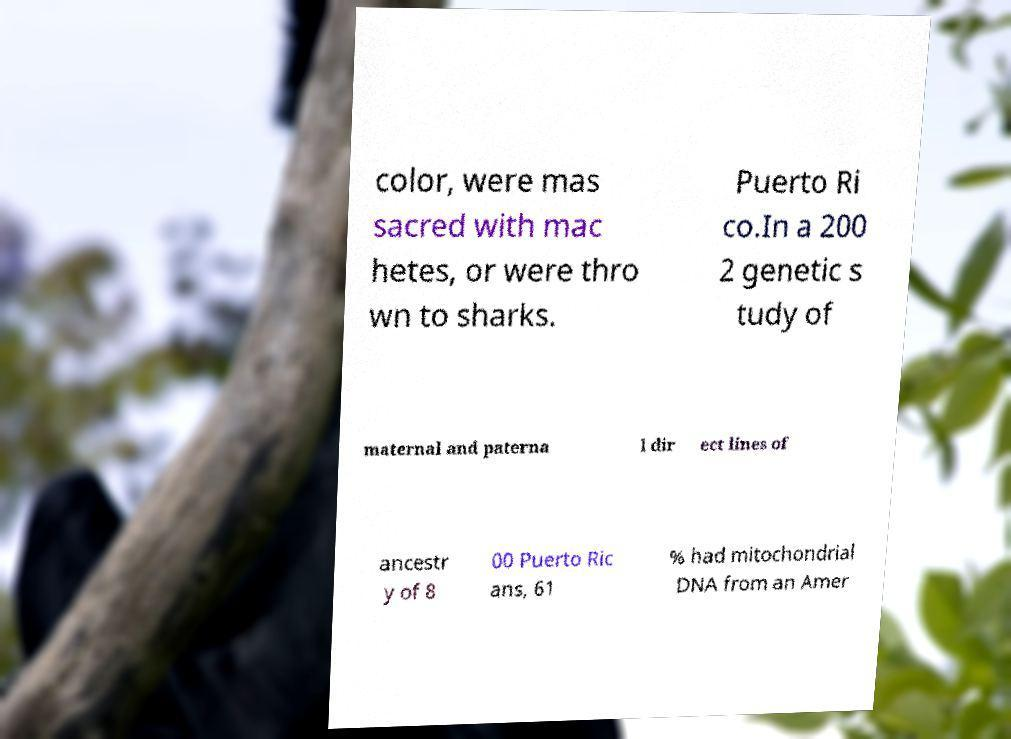I need the written content from this picture converted into text. Can you do that? color, were mas sacred with mac hetes, or were thro wn to sharks. Puerto Ri co.In a 200 2 genetic s tudy of maternal and paterna l dir ect lines of ancestr y of 8 00 Puerto Ric ans, 61 % had mitochondrial DNA from an Amer 